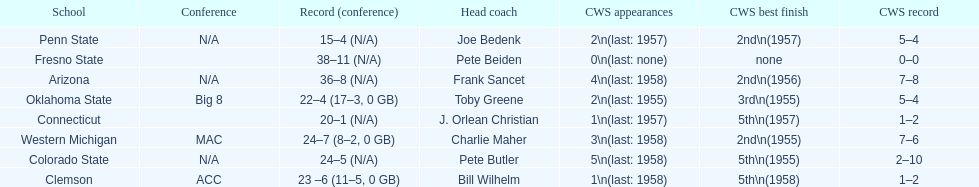Does clemson or western michigan have more cws appearances? Western Michigan. 